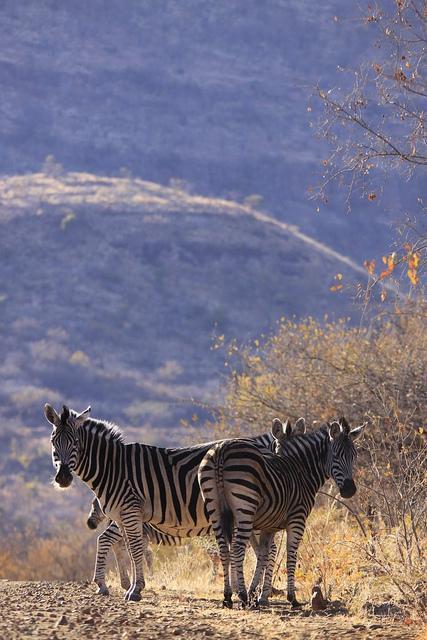How many zebras?
Give a very brief answer. 4. How many animals are standing up in this image?
Give a very brief answer. 2. How many zebras are visible?
Give a very brief answer. 2. How many chairs don't have a dog on them?
Give a very brief answer. 0. 